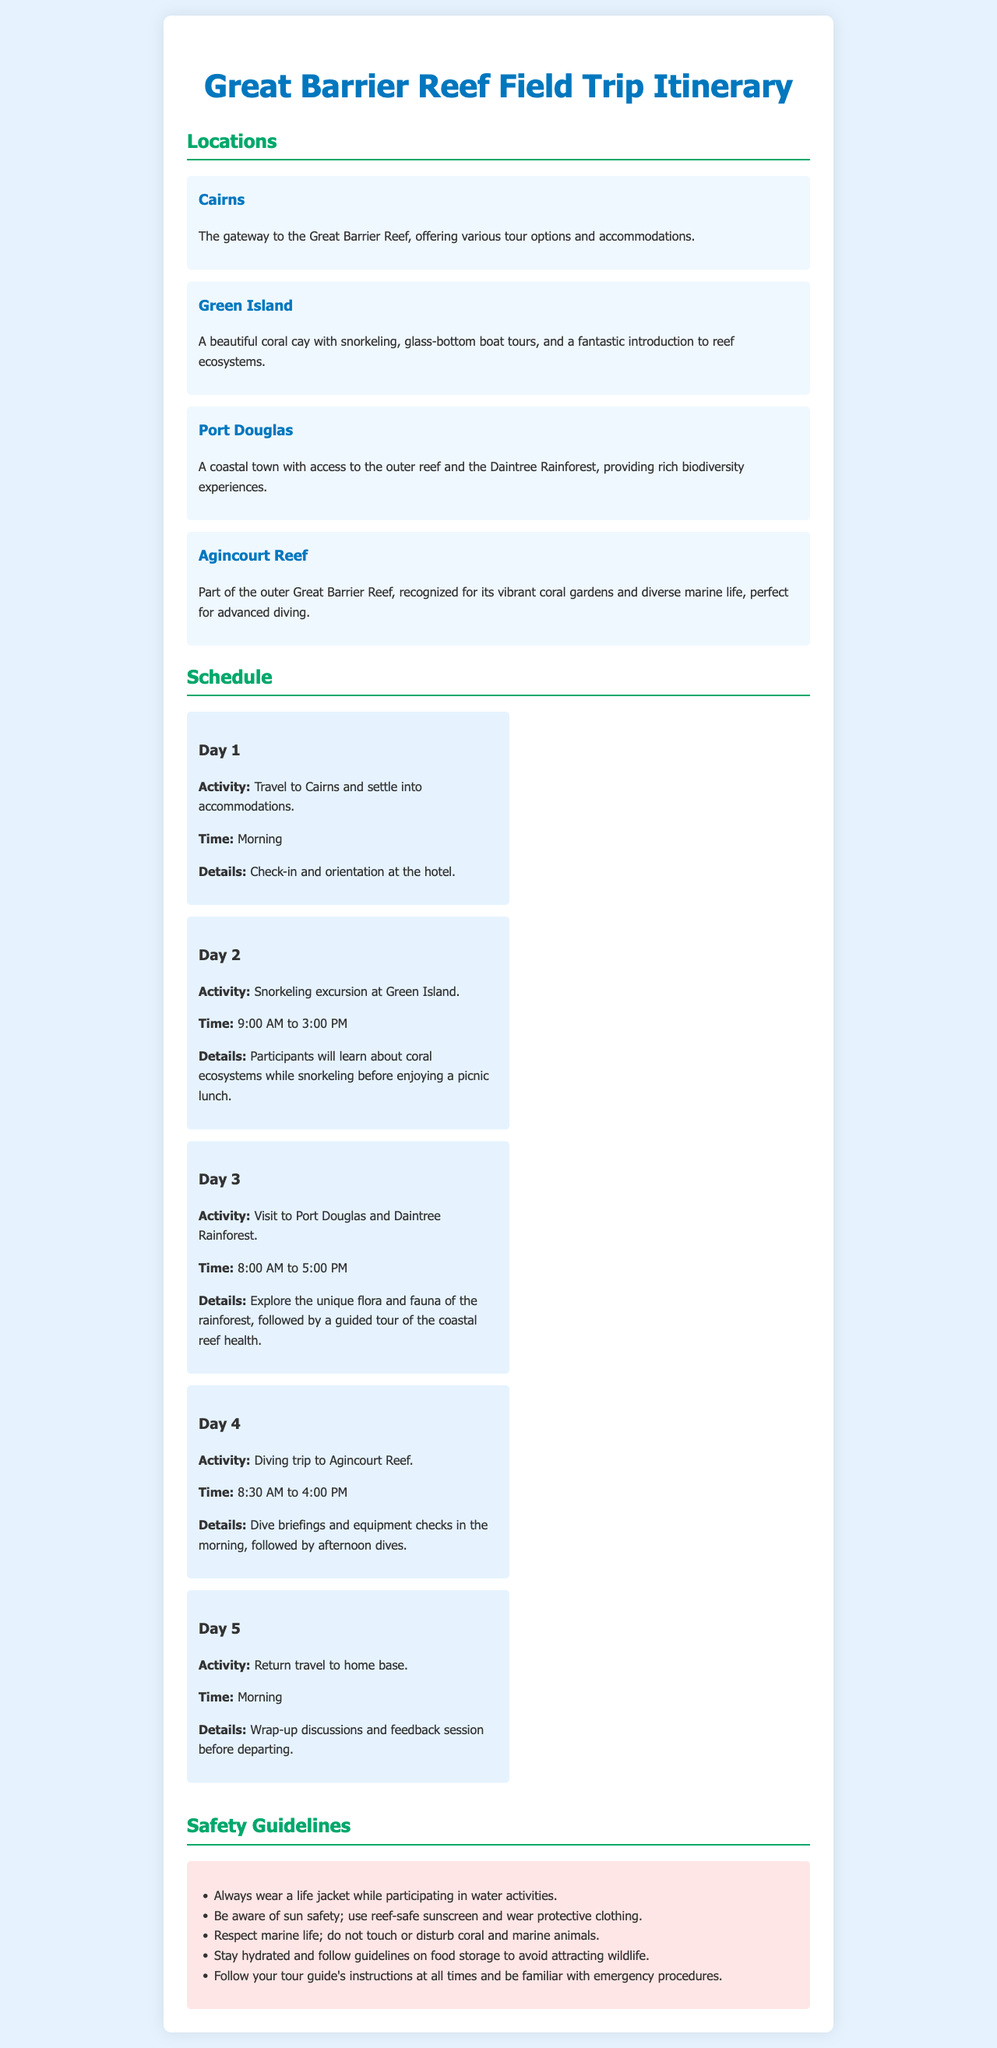What is the title of the document? The title is specified in the header section of the document.
Answer: Great Barrier Reef Field Trip Itinerary What is the first location mentioned in the itinerary? The first location listed in the document is under the Locations section.
Answer: Cairns What time does the snorkeling excursion at Green Island start? The start time is specified in the Day 2 schedule section.
Answer: 9:00 AM How many days does the field trip last? This can be counted from the schedule section which lists day activities.
Answer: 5 What activity occurs on Day 3? The activity for Day 3 is described in the corresponding section of the schedule.
Answer: Visit to Port Douglas and Daintree Rainforest What safety guideline advises on wearing protective clothing? The guideline relating to sun safety mentions protective clothing.
Answer: Be aware of sun safety; use reef-safe sunscreen and wear protective clothing Which location is known for advanced diving? The location recognized for advanced diving is found in the Locations section.
Answer: Agincourt Reef What is the final activity of the field trip? The last activity is detailed in the Day 5 schedule section.
Answer: Return travel to home base 